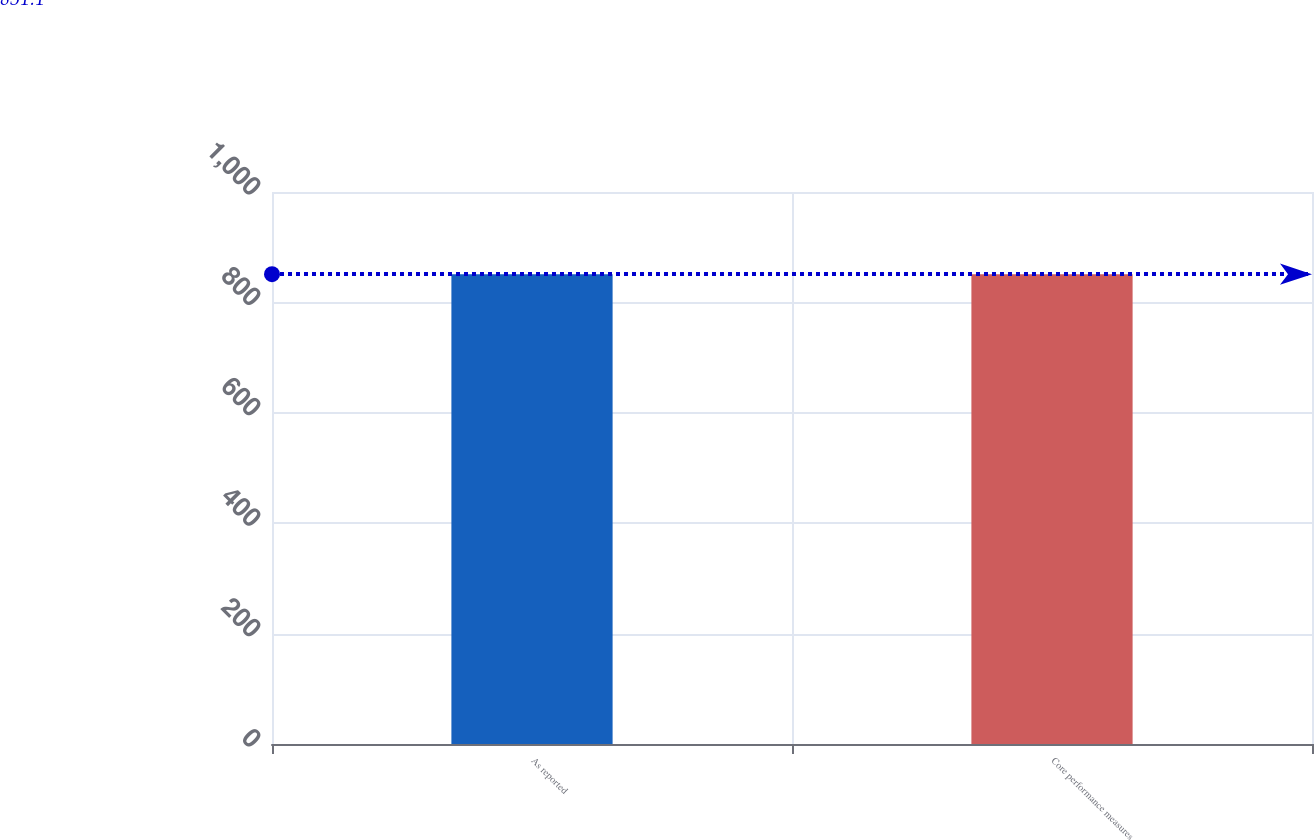Convert chart to OTSL. <chart><loc_0><loc_0><loc_500><loc_500><bar_chart><fcel>As reported<fcel>Core performance measures<nl><fcel>851<fcel>851.1<nl></chart> 